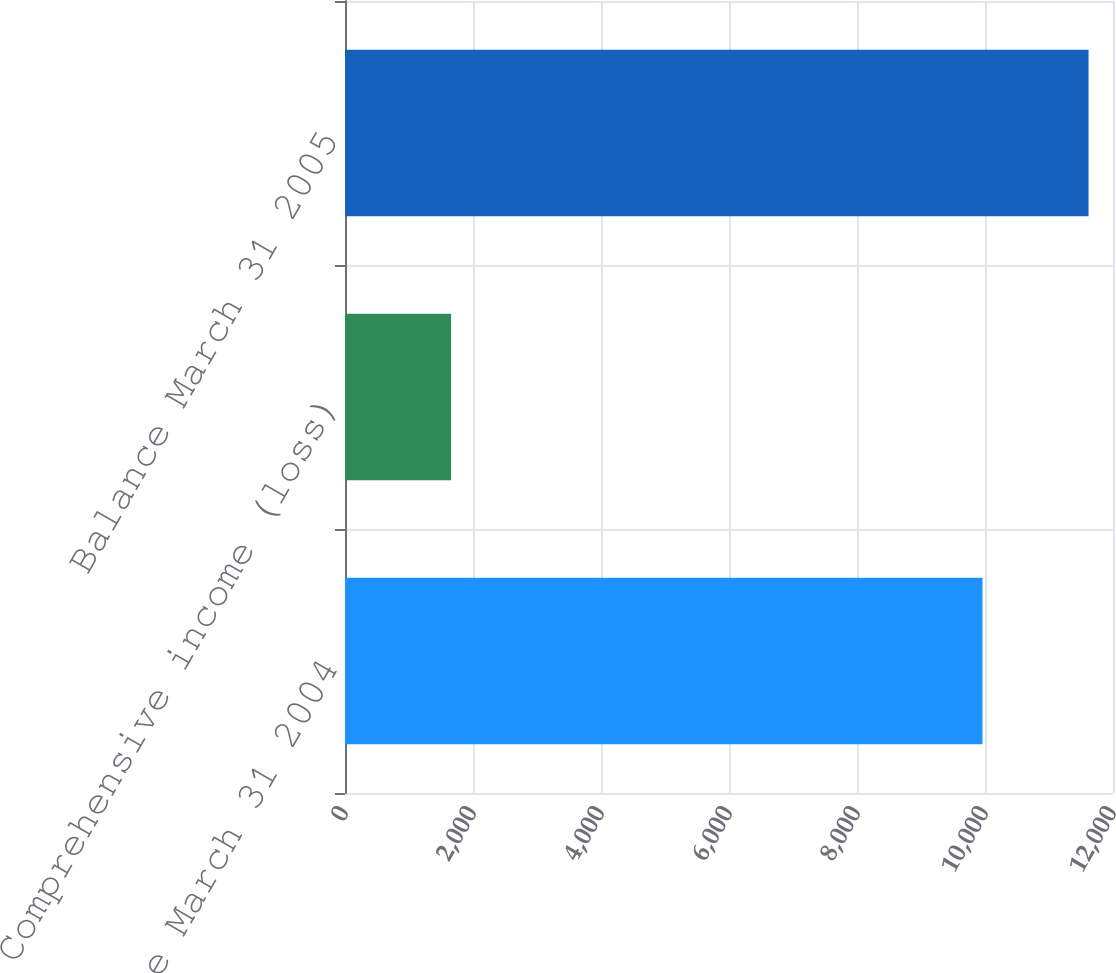<chart> <loc_0><loc_0><loc_500><loc_500><bar_chart><fcel>Balance March 31 2004<fcel>Comprehensive income (loss)<fcel>Balance March 31 2005<nl><fcel>9961<fcel>1657<fcel>11618<nl></chart> 